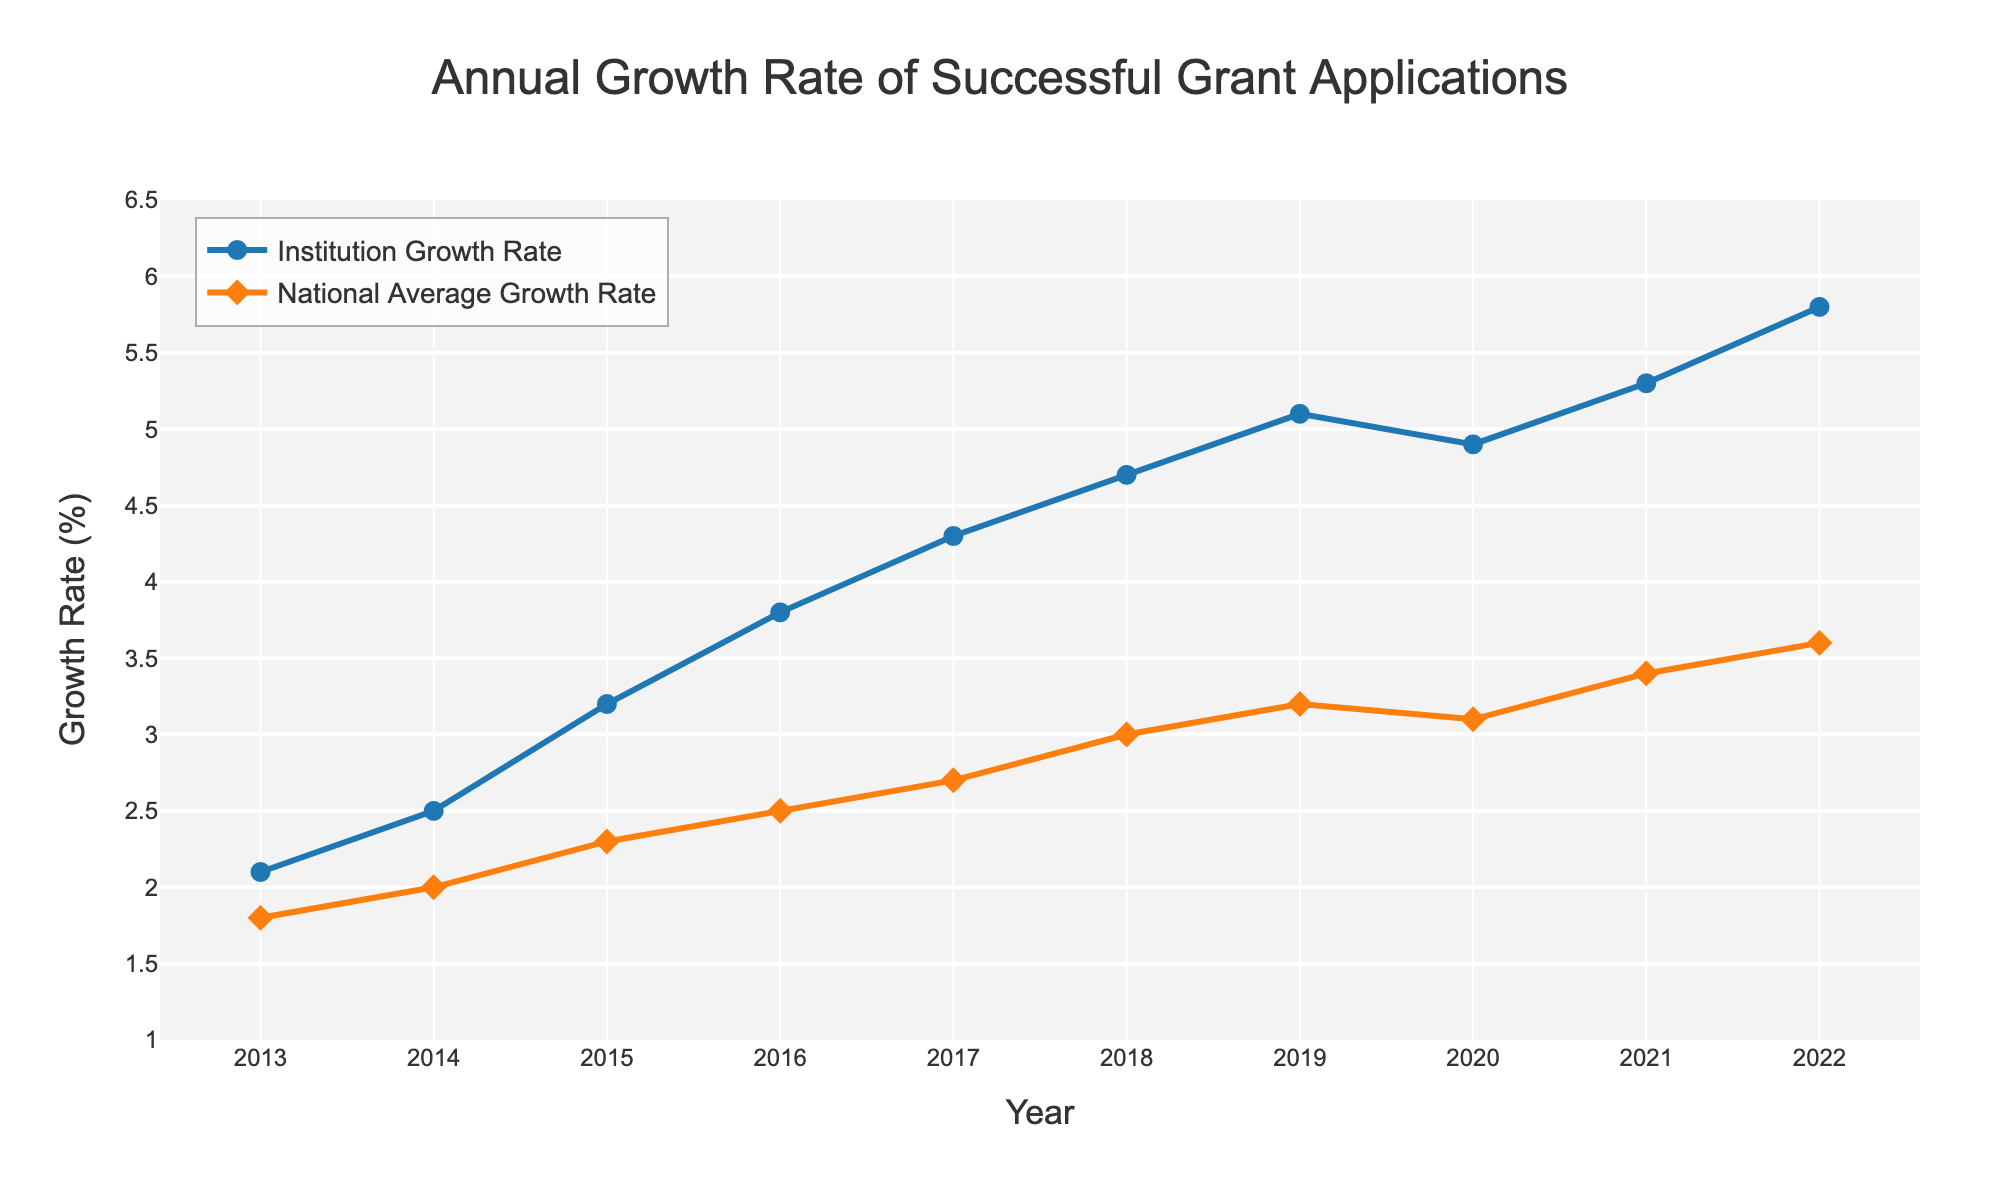What is the highest recorded Institution Growth Rate? The highest point on the line representing the Institution Growth Rate is at 5.8% in the year 2022.
Answer: 5.8% What year did the Institution Growth Rate surpass 5%? On the Institution Growth Rate line, the rate first reaches above 5% between the years 2019 and 2020. In 2019, it is at 5.1%.
Answer: 2019 How does the Institution Growth Rate in 2020 compare to the National Average Growth Rate in the same year? In 2020, the Institution Growth Rate is 4.9%, while the National Average Growth Rate is 3.1%. Therefore, the Institution's rate is higher.
Answer: 4.9% vs. 3.1% What is the difference in growth rate between the Institution and the National Average in 2015? The Institution Growth Rate in 2015 is 3.2%, and the National Average Growth Rate is 2.3%. The difference is calculated as 3.2% - 2.3% = 0.9%.
Answer: 0.9% In which year is the gap between the Institution Growth Rate and the National Average Growth Rate the largest? To find this gap, visually check each year and calculate the difference. The largest difference is between the Institution's 5.8% and the National Average's 3.6% in 2022, which is a gap of 2.2%.
Answer: 2022 Which year shows a decline in the Institution Growth Rate compared to the previous year? Most years show an increasing trend except from 2019 to 2020 where the rate drops from 5.1% to 4.9%.
Answer: 2020 What is the average growth rate of the Institution over the 10 years shown? Sum all the Institution Growth Rates from 2013 to 2022 and divide by the number of years: (2.1 + 2.5 + 3.2 + 3.8 + 4.3 + 4.7 + 5.1 + 4.9 + 5.3 + 5.8) / 10 = 4.17.
Answer: 4.17 Which year's Institution Growth Rate is closest to the National Average Growth Rate in 2021? The National Average Growth Rate in 2021 is 3.4%. The closest Institution Rate to 3.4% is in 2016, at 3.8%.
Answer: 2016 How many years does the Institution Growth Rate exceed the National Average Growth Rate by at least 2%? Visually check the gap each year. The difference is at least 2% in 2022 (2.2%) and 2021 (1.9%, not meeting the threshold). So only in 2022.
Answer: 1 year In what year does the National Average Growth Rate first reach or exceed 3%? Trace the National Average Growth Rate line and find the first year it hits 3%, which is 2018.
Answer: 2018 